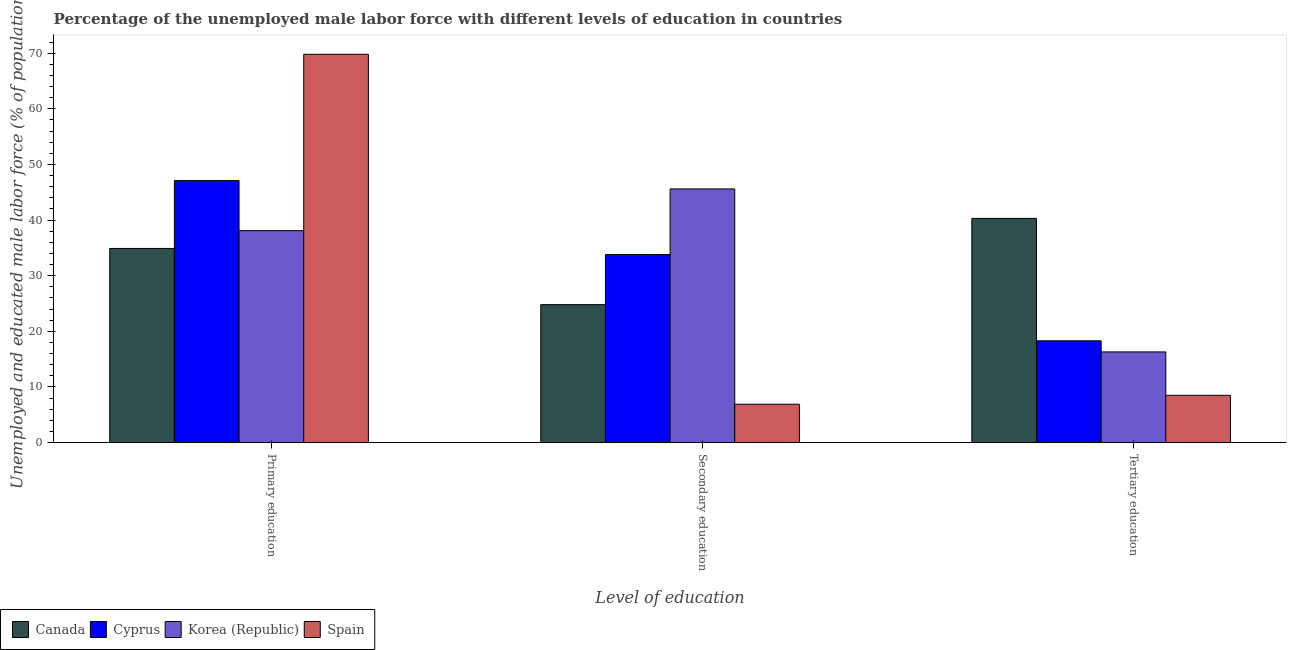How many bars are there on the 1st tick from the right?
Provide a short and direct response. 4. What is the label of the 3rd group of bars from the left?
Offer a very short reply. Tertiary education. What is the percentage of male labor force who received secondary education in Canada?
Offer a terse response. 24.8. Across all countries, what is the maximum percentage of male labor force who received tertiary education?
Your answer should be compact. 40.3. Across all countries, what is the minimum percentage of male labor force who received primary education?
Offer a terse response. 34.9. What is the total percentage of male labor force who received secondary education in the graph?
Offer a terse response. 111.1. What is the difference between the percentage of male labor force who received secondary education in Canada and that in Spain?
Give a very brief answer. 17.9. What is the difference between the percentage of male labor force who received primary education in Canada and the percentage of male labor force who received tertiary education in Cyprus?
Provide a short and direct response. 16.6. What is the average percentage of male labor force who received secondary education per country?
Your answer should be very brief. 27.77. What is the difference between the percentage of male labor force who received secondary education and percentage of male labor force who received tertiary education in Korea (Republic)?
Make the answer very short. 29.3. In how many countries, is the percentage of male labor force who received tertiary education greater than 6 %?
Keep it short and to the point. 4. What is the ratio of the percentage of male labor force who received tertiary education in Canada to that in Spain?
Make the answer very short. 4.74. Is the percentage of male labor force who received secondary education in Canada less than that in Spain?
Provide a short and direct response. No. What is the difference between the highest and the second highest percentage of male labor force who received tertiary education?
Provide a succinct answer. 22. What is the difference between the highest and the lowest percentage of male labor force who received secondary education?
Your answer should be very brief. 38.7. In how many countries, is the percentage of male labor force who received secondary education greater than the average percentage of male labor force who received secondary education taken over all countries?
Keep it short and to the point. 2. Is the sum of the percentage of male labor force who received primary education in Canada and Spain greater than the maximum percentage of male labor force who received secondary education across all countries?
Keep it short and to the point. Yes. What does the 2nd bar from the left in Tertiary education represents?
Ensure brevity in your answer.  Cyprus. What does the 4th bar from the right in Primary education represents?
Give a very brief answer. Canada. Is it the case that in every country, the sum of the percentage of male labor force who received primary education and percentage of male labor force who received secondary education is greater than the percentage of male labor force who received tertiary education?
Offer a terse response. Yes. How many bars are there?
Provide a short and direct response. 12. Are all the bars in the graph horizontal?
Provide a succinct answer. No. How many countries are there in the graph?
Ensure brevity in your answer.  4. What is the difference between two consecutive major ticks on the Y-axis?
Ensure brevity in your answer.  10. Are the values on the major ticks of Y-axis written in scientific E-notation?
Ensure brevity in your answer.  No. Does the graph contain any zero values?
Provide a short and direct response. No. What is the title of the graph?
Keep it short and to the point. Percentage of the unemployed male labor force with different levels of education in countries. What is the label or title of the X-axis?
Make the answer very short. Level of education. What is the label or title of the Y-axis?
Keep it short and to the point. Unemployed and educated male labor force (% of population). What is the Unemployed and educated male labor force (% of population) of Canada in Primary education?
Ensure brevity in your answer.  34.9. What is the Unemployed and educated male labor force (% of population) in Cyprus in Primary education?
Ensure brevity in your answer.  47.1. What is the Unemployed and educated male labor force (% of population) of Korea (Republic) in Primary education?
Your answer should be very brief. 38.1. What is the Unemployed and educated male labor force (% of population) of Spain in Primary education?
Offer a terse response. 69.8. What is the Unemployed and educated male labor force (% of population) of Canada in Secondary education?
Give a very brief answer. 24.8. What is the Unemployed and educated male labor force (% of population) in Cyprus in Secondary education?
Provide a succinct answer. 33.8. What is the Unemployed and educated male labor force (% of population) of Korea (Republic) in Secondary education?
Ensure brevity in your answer.  45.6. What is the Unemployed and educated male labor force (% of population) in Spain in Secondary education?
Ensure brevity in your answer.  6.9. What is the Unemployed and educated male labor force (% of population) of Canada in Tertiary education?
Your response must be concise. 40.3. What is the Unemployed and educated male labor force (% of population) in Cyprus in Tertiary education?
Give a very brief answer. 18.3. What is the Unemployed and educated male labor force (% of population) of Korea (Republic) in Tertiary education?
Your response must be concise. 16.3. What is the Unemployed and educated male labor force (% of population) in Spain in Tertiary education?
Offer a very short reply. 8.5. Across all Level of education, what is the maximum Unemployed and educated male labor force (% of population) in Canada?
Provide a succinct answer. 40.3. Across all Level of education, what is the maximum Unemployed and educated male labor force (% of population) in Cyprus?
Offer a very short reply. 47.1. Across all Level of education, what is the maximum Unemployed and educated male labor force (% of population) in Korea (Republic)?
Ensure brevity in your answer.  45.6. Across all Level of education, what is the maximum Unemployed and educated male labor force (% of population) in Spain?
Keep it short and to the point. 69.8. Across all Level of education, what is the minimum Unemployed and educated male labor force (% of population) of Canada?
Give a very brief answer. 24.8. Across all Level of education, what is the minimum Unemployed and educated male labor force (% of population) of Cyprus?
Your response must be concise. 18.3. Across all Level of education, what is the minimum Unemployed and educated male labor force (% of population) in Korea (Republic)?
Offer a very short reply. 16.3. Across all Level of education, what is the minimum Unemployed and educated male labor force (% of population) in Spain?
Your answer should be very brief. 6.9. What is the total Unemployed and educated male labor force (% of population) of Cyprus in the graph?
Your answer should be compact. 99.2. What is the total Unemployed and educated male labor force (% of population) of Korea (Republic) in the graph?
Give a very brief answer. 100. What is the total Unemployed and educated male labor force (% of population) of Spain in the graph?
Provide a short and direct response. 85.2. What is the difference between the Unemployed and educated male labor force (% of population) in Cyprus in Primary education and that in Secondary education?
Keep it short and to the point. 13.3. What is the difference between the Unemployed and educated male labor force (% of population) of Korea (Republic) in Primary education and that in Secondary education?
Provide a succinct answer. -7.5. What is the difference between the Unemployed and educated male labor force (% of population) in Spain in Primary education and that in Secondary education?
Offer a terse response. 62.9. What is the difference between the Unemployed and educated male labor force (% of population) of Canada in Primary education and that in Tertiary education?
Ensure brevity in your answer.  -5.4. What is the difference between the Unemployed and educated male labor force (% of population) in Cyprus in Primary education and that in Tertiary education?
Your answer should be compact. 28.8. What is the difference between the Unemployed and educated male labor force (% of population) of Korea (Republic) in Primary education and that in Tertiary education?
Keep it short and to the point. 21.8. What is the difference between the Unemployed and educated male labor force (% of population) in Spain in Primary education and that in Tertiary education?
Offer a very short reply. 61.3. What is the difference between the Unemployed and educated male labor force (% of population) of Canada in Secondary education and that in Tertiary education?
Your answer should be compact. -15.5. What is the difference between the Unemployed and educated male labor force (% of population) in Korea (Republic) in Secondary education and that in Tertiary education?
Ensure brevity in your answer.  29.3. What is the difference between the Unemployed and educated male labor force (% of population) in Spain in Secondary education and that in Tertiary education?
Offer a terse response. -1.6. What is the difference between the Unemployed and educated male labor force (% of population) of Canada in Primary education and the Unemployed and educated male labor force (% of population) of Cyprus in Secondary education?
Make the answer very short. 1.1. What is the difference between the Unemployed and educated male labor force (% of population) in Canada in Primary education and the Unemployed and educated male labor force (% of population) in Spain in Secondary education?
Give a very brief answer. 28. What is the difference between the Unemployed and educated male labor force (% of population) of Cyprus in Primary education and the Unemployed and educated male labor force (% of population) of Korea (Republic) in Secondary education?
Offer a terse response. 1.5. What is the difference between the Unemployed and educated male labor force (% of population) in Cyprus in Primary education and the Unemployed and educated male labor force (% of population) in Spain in Secondary education?
Your answer should be compact. 40.2. What is the difference between the Unemployed and educated male labor force (% of population) in Korea (Republic) in Primary education and the Unemployed and educated male labor force (% of population) in Spain in Secondary education?
Offer a terse response. 31.2. What is the difference between the Unemployed and educated male labor force (% of population) of Canada in Primary education and the Unemployed and educated male labor force (% of population) of Cyprus in Tertiary education?
Make the answer very short. 16.6. What is the difference between the Unemployed and educated male labor force (% of population) in Canada in Primary education and the Unemployed and educated male labor force (% of population) in Korea (Republic) in Tertiary education?
Offer a terse response. 18.6. What is the difference between the Unemployed and educated male labor force (% of population) of Canada in Primary education and the Unemployed and educated male labor force (% of population) of Spain in Tertiary education?
Your answer should be compact. 26.4. What is the difference between the Unemployed and educated male labor force (% of population) of Cyprus in Primary education and the Unemployed and educated male labor force (% of population) of Korea (Republic) in Tertiary education?
Make the answer very short. 30.8. What is the difference between the Unemployed and educated male labor force (% of population) of Cyprus in Primary education and the Unemployed and educated male labor force (% of population) of Spain in Tertiary education?
Your response must be concise. 38.6. What is the difference between the Unemployed and educated male labor force (% of population) of Korea (Republic) in Primary education and the Unemployed and educated male labor force (% of population) of Spain in Tertiary education?
Provide a short and direct response. 29.6. What is the difference between the Unemployed and educated male labor force (% of population) of Canada in Secondary education and the Unemployed and educated male labor force (% of population) of Cyprus in Tertiary education?
Offer a terse response. 6.5. What is the difference between the Unemployed and educated male labor force (% of population) of Canada in Secondary education and the Unemployed and educated male labor force (% of population) of Korea (Republic) in Tertiary education?
Your answer should be compact. 8.5. What is the difference between the Unemployed and educated male labor force (% of population) of Canada in Secondary education and the Unemployed and educated male labor force (% of population) of Spain in Tertiary education?
Give a very brief answer. 16.3. What is the difference between the Unemployed and educated male labor force (% of population) of Cyprus in Secondary education and the Unemployed and educated male labor force (% of population) of Spain in Tertiary education?
Provide a succinct answer. 25.3. What is the difference between the Unemployed and educated male labor force (% of population) in Korea (Republic) in Secondary education and the Unemployed and educated male labor force (% of population) in Spain in Tertiary education?
Your answer should be very brief. 37.1. What is the average Unemployed and educated male labor force (% of population) of Canada per Level of education?
Your answer should be very brief. 33.33. What is the average Unemployed and educated male labor force (% of population) of Cyprus per Level of education?
Offer a terse response. 33.07. What is the average Unemployed and educated male labor force (% of population) in Korea (Republic) per Level of education?
Ensure brevity in your answer.  33.33. What is the average Unemployed and educated male labor force (% of population) of Spain per Level of education?
Offer a terse response. 28.4. What is the difference between the Unemployed and educated male labor force (% of population) of Canada and Unemployed and educated male labor force (% of population) of Spain in Primary education?
Ensure brevity in your answer.  -34.9. What is the difference between the Unemployed and educated male labor force (% of population) in Cyprus and Unemployed and educated male labor force (% of population) in Korea (Republic) in Primary education?
Offer a very short reply. 9. What is the difference between the Unemployed and educated male labor force (% of population) in Cyprus and Unemployed and educated male labor force (% of population) in Spain in Primary education?
Make the answer very short. -22.7. What is the difference between the Unemployed and educated male labor force (% of population) of Korea (Republic) and Unemployed and educated male labor force (% of population) of Spain in Primary education?
Your answer should be very brief. -31.7. What is the difference between the Unemployed and educated male labor force (% of population) in Canada and Unemployed and educated male labor force (% of population) in Korea (Republic) in Secondary education?
Offer a terse response. -20.8. What is the difference between the Unemployed and educated male labor force (% of population) of Canada and Unemployed and educated male labor force (% of population) of Spain in Secondary education?
Your response must be concise. 17.9. What is the difference between the Unemployed and educated male labor force (% of population) in Cyprus and Unemployed and educated male labor force (% of population) in Spain in Secondary education?
Your response must be concise. 26.9. What is the difference between the Unemployed and educated male labor force (% of population) of Korea (Republic) and Unemployed and educated male labor force (% of population) of Spain in Secondary education?
Offer a very short reply. 38.7. What is the difference between the Unemployed and educated male labor force (% of population) of Canada and Unemployed and educated male labor force (% of population) of Cyprus in Tertiary education?
Provide a succinct answer. 22. What is the difference between the Unemployed and educated male labor force (% of population) in Canada and Unemployed and educated male labor force (% of population) in Korea (Republic) in Tertiary education?
Your answer should be very brief. 24. What is the difference between the Unemployed and educated male labor force (% of population) in Canada and Unemployed and educated male labor force (% of population) in Spain in Tertiary education?
Your response must be concise. 31.8. What is the difference between the Unemployed and educated male labor force (% of population) of Cyprus and Unemployed and educated male labor force (% of population) of Korea (Republic) in Tertiary education?
Your response must be concise. 2. What is the difference between the Unemployed and educated male labor force (% of population) of Cyprus and Unemployed and educated male labor force (% of population) of Spain in Tertiary education?
Your answer should be compact. 9.8. What is the difference between the Unemployed and educated male labor force (% of population) of Korea (Republic) and Unemployed and educated male labor force (% of population) of Spain in Tertiary education?
Your answer should be very brief. 7.8. What is the ratio of the Unemployed and educated male labor force (% of population) of Canada in Primary education to that in Secondary education?
Provide a short and direct response. 1.41. What is the ratio of the Unemployed and educated male labor force (% of population) of Cyprus in Primary education to that in Secondary education?
Provide a short and direct response. 1.39. What is the ratio of the Unemployed and educated male labor force (% of population) of Korea (Republic) in Primary education to that in Secondary education?
Your response must be concise. 0.84. What is the ratio of the Unemployed and educated male labor force (% of population) in Spain in Primary education to that in Secondary education?
Your answer should be compact. 10.12. What is the ratio of the Unemployed and educated male labor force (% of population) of Canada in Primary education to that in Tertiary education?
Offer a very short reply. 0.87. What is the ratio of the Unemployed and educated male labor force (% of population) of Cyprus in Primary education to that in Tertiary education?
Keep it short and to the point. 2.57. What is the ratio of the Unemployed and educated male labor force (% of population) of Korea (Republic) in Primary education to that in Tertiary education?
Your answer should be compact. 2.34. What is the ratio of the Unemployed and educated male labor force (% of population) of Spain in Primary education to that in Tertiary education?
Your answer should be very brief. 8.21. What is the ratio of the Unemployed and educated male labor force (% of population) in Canada in Secondary education to that in Tertiary education?
Provide a short and direct response. 0.62. What is the ratio of the Unemployed and educated male labor force (% of population) in Cyprus in Secondary education to that in Tertiary education?
Make the answer very short. 1.85. What is the ratio of the Unemployed and educated male labor force (% of population) in Korea (Republic) in Secondary education to that in Tertiary education?
Make the answer very short. 2.8. What is the ratio of the Unemployed and educated male labor force (% of population) of Spain in Secondary education to that in Tertiary education?
Provide a short and direct response. 0.81. What is the difference between the highest and the second highest Unemployed and educated male labor force (% of population) of Cyprus?
Keep it short and to the point. 13.3. What is the difference between the highest and the second highest Unemployed and educated male labor force (% of population) of Korea (Republic)?
Your answer should be very brief. 7.5. What is the difference between the highest and the second highest Unemployed and educated male labor force (% of population) in Spain?
Keep it short and to the point. 61.3. What is the difference between the highest and the lowest Unemployed and educated male labor force (% of population) of Canada?
Give a very brief answer. 15.5. What is the difference between the highest and the lowest Unemployed and educated male labor force (% of population) in Cyprus?
Keep it short and to the point. 28.8. What is the difference between the highest and the lowest Unemployed and educated male labor force (% of population) of Korea (Republic)?
Keep it short and to the point. 29.3. What is the difference between the highest and the lowest Unemployed and educated male labor force (% of population) in Spain?
Your answer should be very brief. 62.9. 